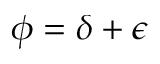Convert formula to latex. <formula><loc_0><loc_0><loc_500><loc_500>\phi = \delta + \epsilon</formula> 